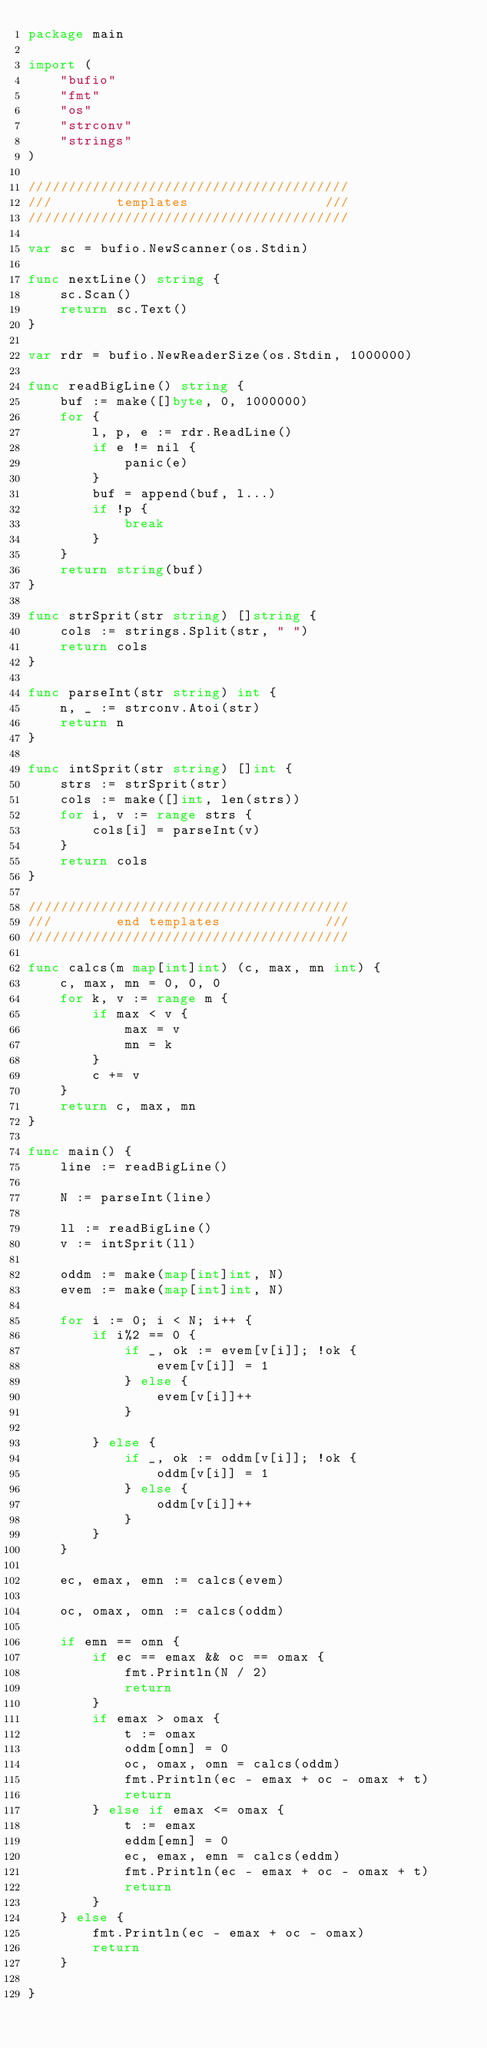<code> <loc_0><loc_0><loc_500><loc_500><_Go_>package main

import (
	"bufio"
	"fmt"
	"os"
	"strconv"
	"strings"
)

////////////////////////////////////////
///        templates                 ///
////////////////////////////////////////

var sc = bufio.NewScanner(os.Stdin)

func nextLine() string {
	sc.Scan()
	return sc.Text()
}

var rdr = bufio.NewReaderSize(os.Stdin, 1000000)

func readBigLine() string {
	buf := make([]byte, 0, 1000000)
	for {
		l, p, e := rdr.ReadLine()
		if e != nil {
			panic(e)
		}
		buf = append(buf, l...)
		if !p {
			break
		}
	}
	return string(buf)
}

func strSprit(str string) []string {
	cols := strings.Split(str, " ")
	return cols
}

func parseInt(str string) int {
	n, _ := strconv.Atoi(str)
	return n
}

func intSprit(str string) []int {
	strs := strSprit(str)
	cols := make([]int, len(strs))
	for i, v := range strs {
		cols[i] = parseInt(v)
	}
	return cols
}

////////////////////////////////////////
///        end templates             ///
////////////////////////////////////////

func calcs(m map[int]int) (c, max, mn int) {
	c, max, mn = 0, 0, 0
	for k, v := range m {
		if max < v {
			max = v
			mn = k
		}
		c += v
	}
	return c, max, mn
}

func main() {
	line := readBigLine()

	N := parseInt(line)

	ll := readBigLine()
	v := intSprit(ll)

	oddm := make(map[int]int, N)
	evem := make(map[int]int, N)

	for i := 0; i < N; i++ {
		if i%2 == 0 {
			if _, ok := evem[v[i]]; !ok {
				evem[v[i]] = 1
			} else {
				evem[v[i]]++
			}

		} else {
			if _, ok := oddm[v[i]]; !ok {
				oddm[v[i]] = 1
			} else {
				oddm[v[i]]++
			}
		}
	}

	ec, emax, emn := calcs(evem)

	oc, omax, omn := calcs(oddm)

	if emn == omn {
		if ec == emax && oc == omax {
			fmt.Println(N / 2)
			return
		}
		if emax > omax {
			t := omax
			oddm[omn] = 0
			oc, omax, omn = calcs(oddm)
			fmt.Println(ec - emax + oc - omax + t)
			return
		} else if emax <= omax {
			t := emax
			eddm[emn] = 0
			ec, emax, emn = calcs(eddm)
			fmt.Println(ec - emax + oc - omax + t)
			return
		}
	} else {
		fmt.Println(ec - emax + oc - omax)
		return
	}

}
</code> 